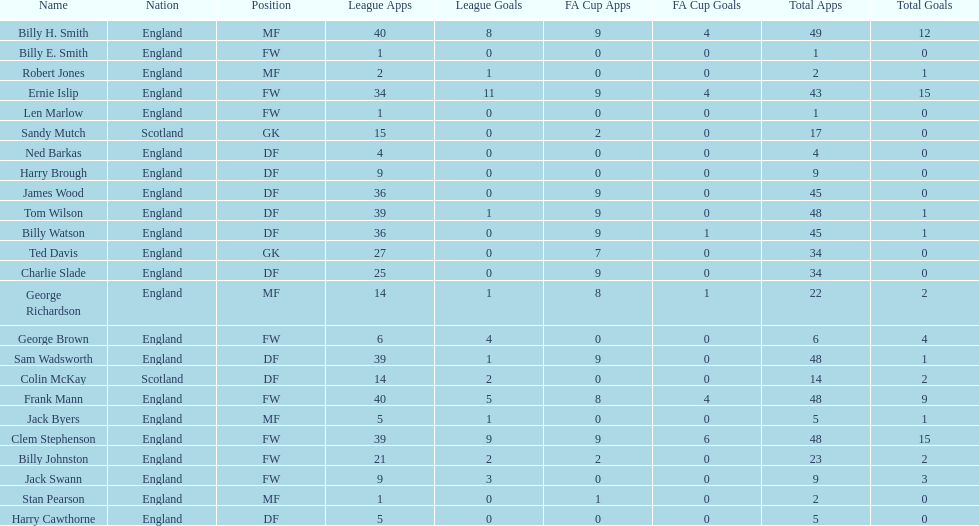What is the last name listed on this chart? James Wood. 